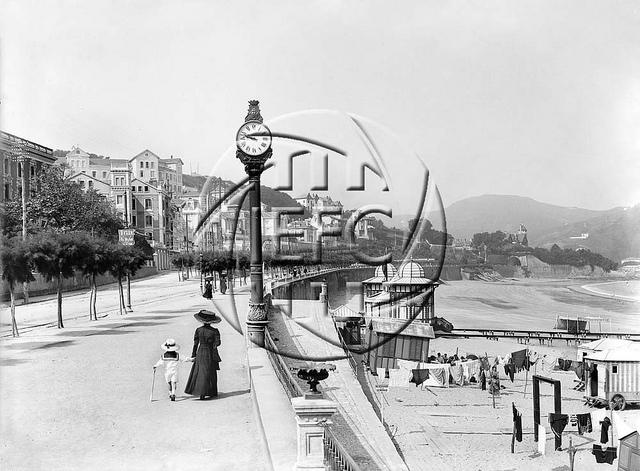Where is the clock pole?
Keep it brief. By sidewalk. What is on the woman's head?
Quick response, please. Hat. Is this a modern picture?
Concise answer only. No. 